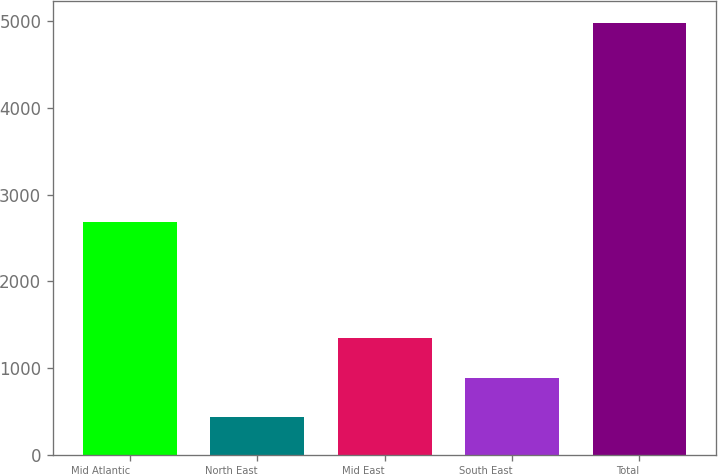Convert chart to OTSL. <chart><loc_0><loc_0><loc_500><loc_500><bar_chart><fcel>Mid Atlantic<fcel>North East<fcel>Mid East<fcel>South East<fcel>Total<nl><fcel>2683<fcel>433<fcel>1342.2<fcel>887.6<fcel>4979<nl></chart> 